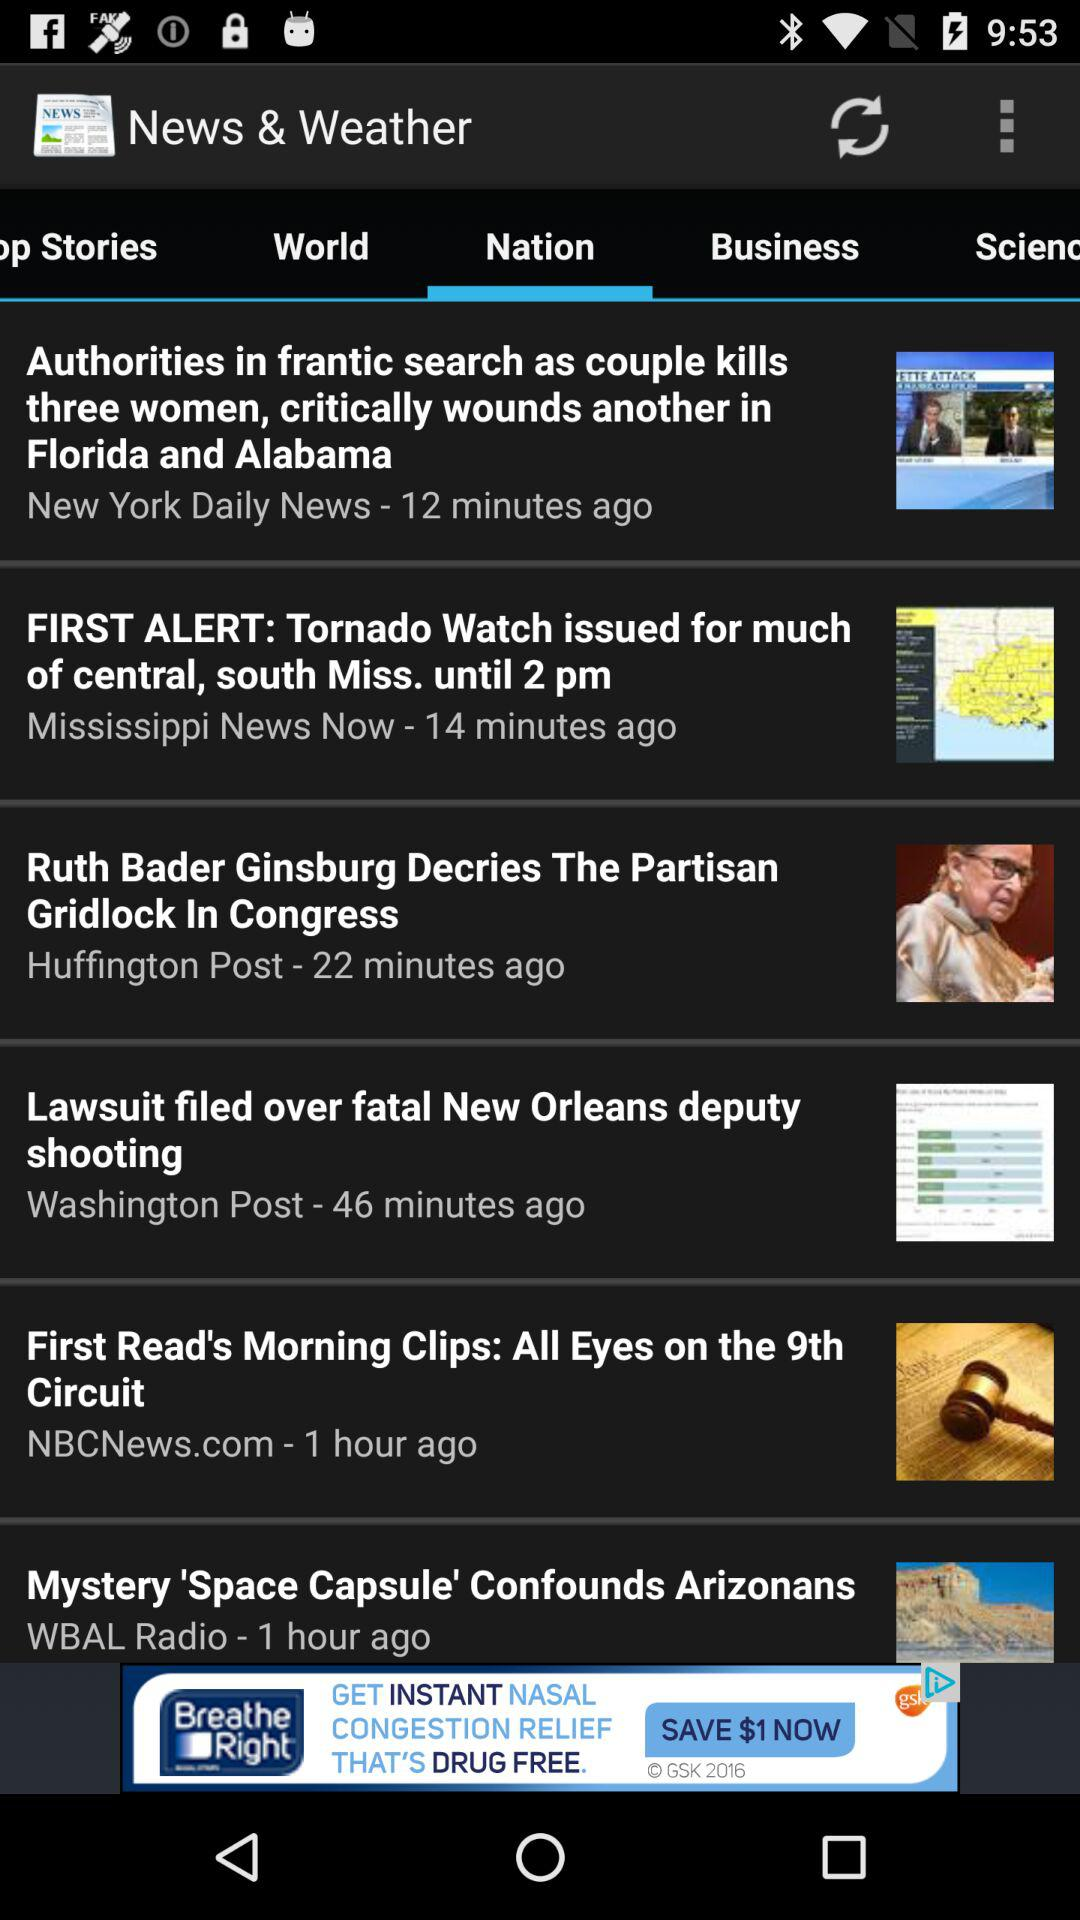Which tab are we on? You are on the "Nation" tab. 